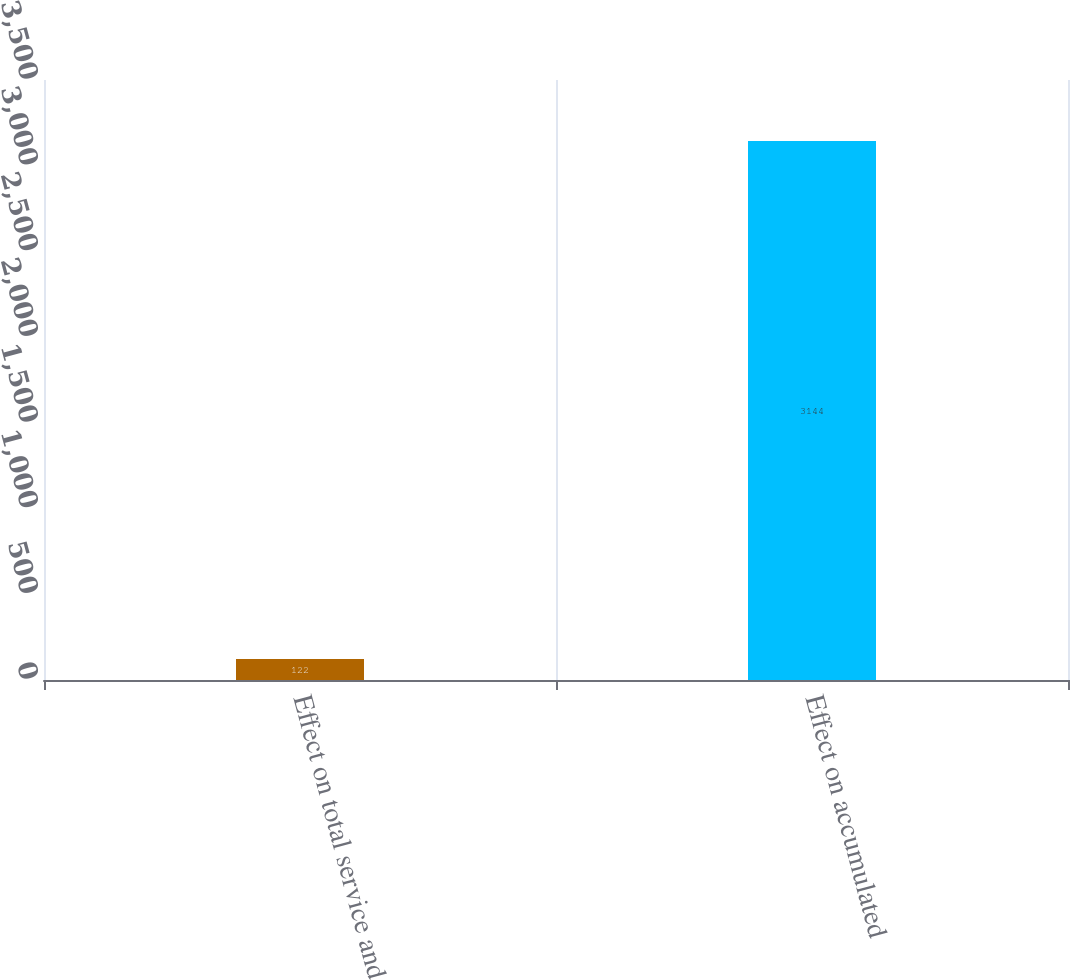Convert chart. <chart><loc_0><loc_0><loc_500><loc_500><bar_chart><fcel>Effect on total service and<fcel>Effect on accumulated<nl><fcel>122<fcel>3144<nl></chart> 